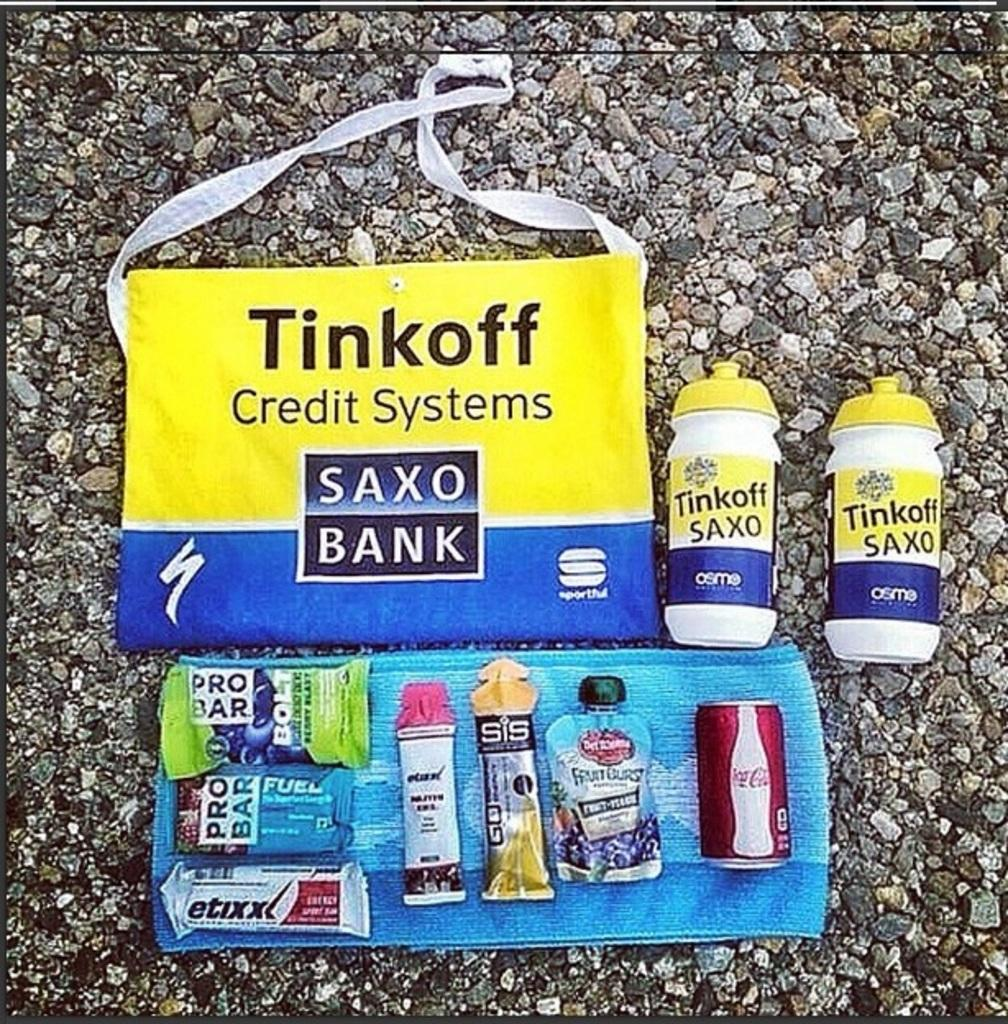<image>
Give a short and clear explanation of the subsequent image. a small bag that is labeled 'tinkoff credit systems saxo bank' 